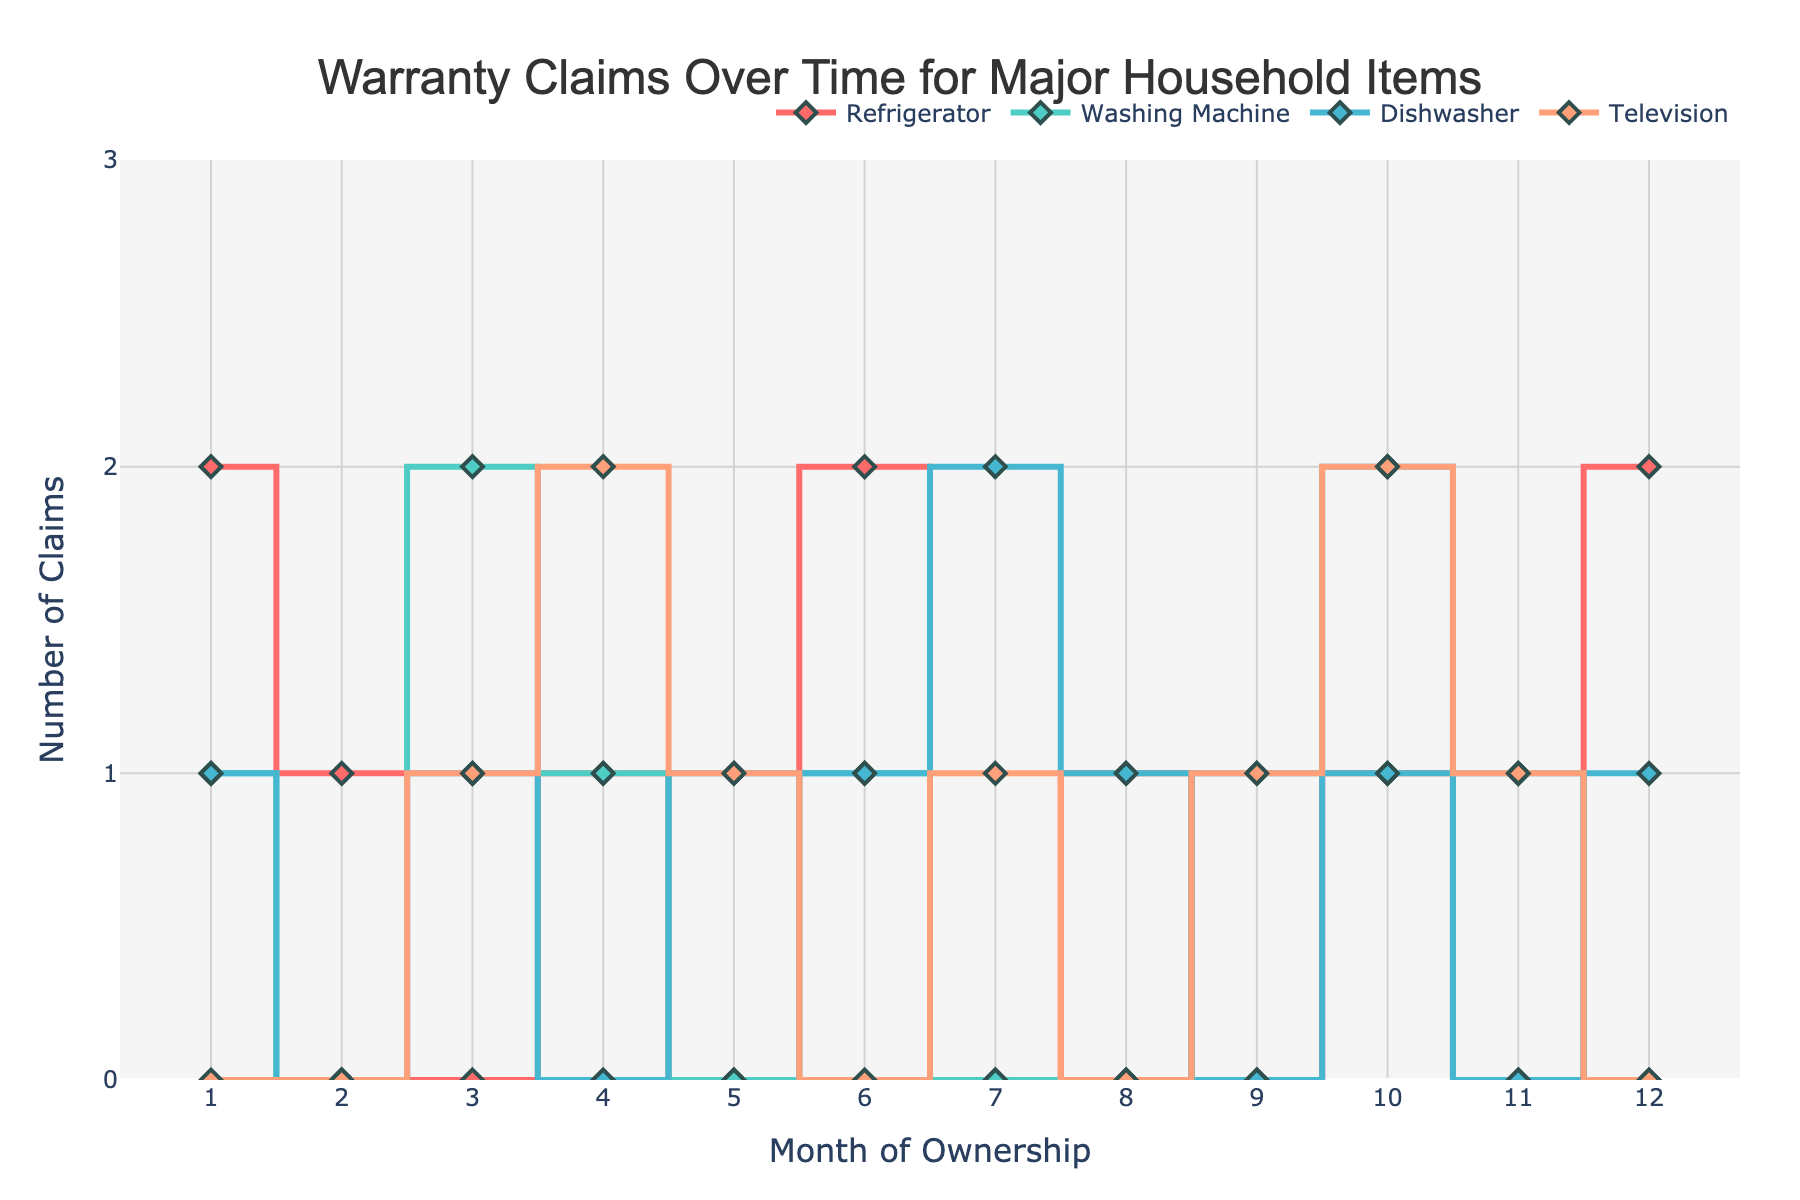What is the title of the figure? The title is typically located at the top of the figure, usually in a larger or bold font that makes it stand out from other text elements.
Answer: Warranty Claims Over Time for Major Household Items Which appliance has the highest number of warranty claims in Month 3? Inspect the data points for each appliance at Month 3 and identify the one with the maximum value. The refrigerator has 0, the washing machine has 2, the dishwasher has 1, and the television has 1.
Answer: Washing Machine How many warranty claims were made for the Television in Month 10? Locate the data point for the Television at Month 10. It falls at the point with an 'x' value of 10 and 'y' value of 2.
Answer: 2 What is the average number of claims for the Refrigerator over the 12 months? Sum the number of claims for each month for the Refrigerator (2 + 1 + 0 + 1 + 0 + 2 + 0 + 1 + 0 + 1 + 0 + 2) = 10, then divide by the number of months (12). 10 / 12 ≈ 0.83
Answer: 0.83 Which month saw the highest total number of warranty claims across all appliances? Add the number of claims for each appliance in each month and then find the month with the highest total sum. For example, Month 3 has 0 (Refrigerator) + 2 (Washing Machine) + 1 (Dishwasher) + 1 (Television) = 4, and repeat for each month. Month 10 has the highest total: 1 + 2 + 1 + 2 = 6.
Answer: Month 10 Did the number of Dishwasher claims increase, decrease, or stay the same from Month 6 to Month 7? Look at the number of claims for the Dishwasher at Month 6 (1) and Month 7 (2). Since 2 is greater than 1, the claims increased.
Answer: Increased Compare the total number of claims between Refrigerators and Televisions. Which had more claims? Sum the total number of claims for Refrigerators (2 + 1 + 0 + 1 + 0 + 2 + 0 + 1 + 0 + 1 + 0 + 2 = 10) and Televisions (0 + 0 + 1 + 2 + 1 + 0 + 1 + 0 + 1 + 2 + 1 + 0 = 9). The Refrigerator has more claims.
Answer: Refrigerators What is the trend for warranty claims for Washing Machines over the period of ownership? Observe the pattern of data points for the Washing Machine. The number of claims seems to oscillate without a clear increasing or decreasing trend, showing periodic spikes.
Answer: Oscillating with periodic spikes 